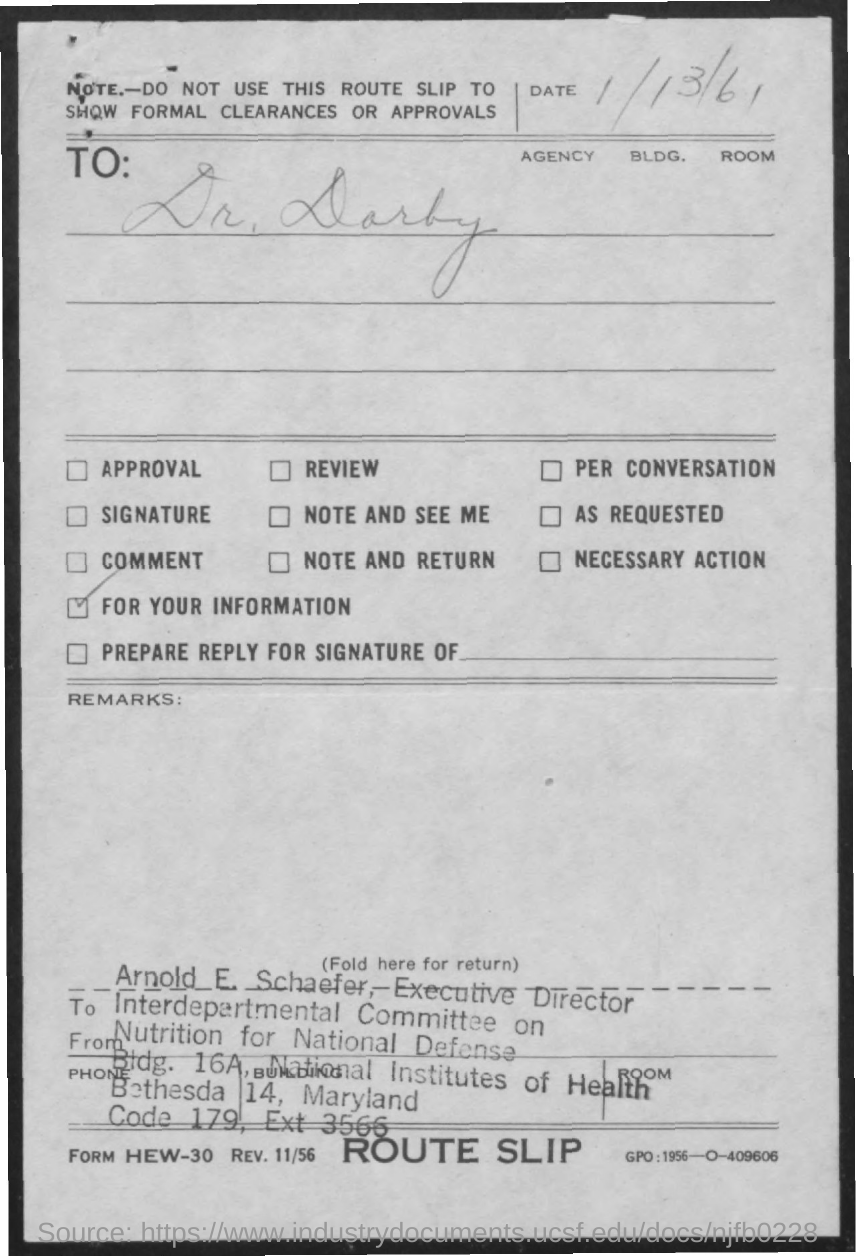Highlight a few significant elements in this photo. Arnold E. Schaefer is the Executive Director of the Interdepartmental Committee on Nutrition for National Defense. According to the document, the date mentioned is 1/13/61. 